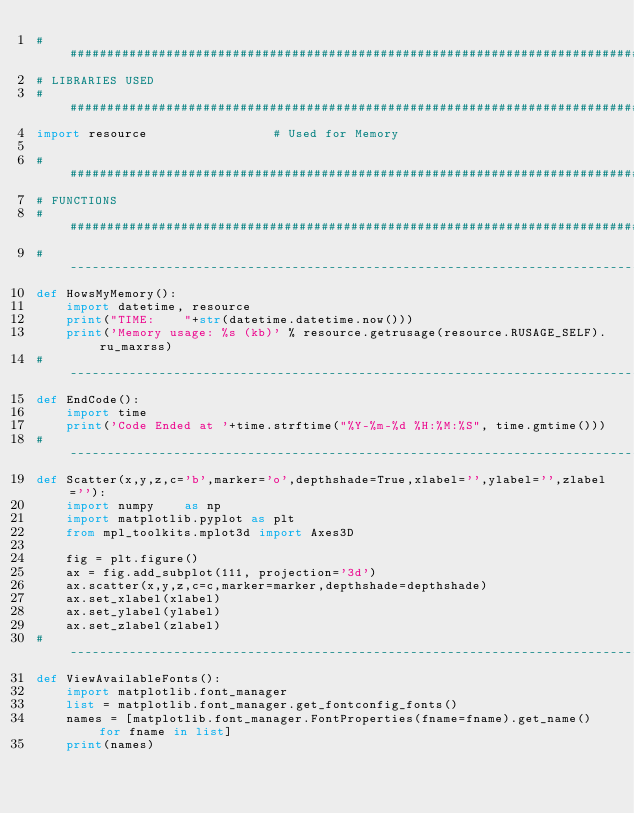Convert code to text. <code><loc_0><loc_0><loc_500><loc_500><_Python_>################################################################################
# LIBRARIES USED
################################################################################
import resource                 # Used for Memory

################################################################################
# FUNCTIONS
################################################################################
#-------------------------------------------------------------------------------
def HowsMyMemory():
    import datetime, resource
    print("TIME:    "+str(datetime.datetime.now()))
    print('Memory usage: %s (kb)' % resource.getrusage(resource.RUSAGE_SELF).ru_maxrss)
#-------------------------------------------------------------------------------
def EndCode():
    import time
    print('Code Ended at '+time.strftime("%Y-%m-%d %H:%M:%S", time.gmtime()))
#-------------------------------------------------------------------------------
def Scatter(x,y,z,c='b',marker='o',depthshade=True,xlabel='',ylabel='',zlabel=''):
    import numpy    as np
    import matplotlib.pyplot as plt
    from mpl_toolkits.mplot3d import Axes3D

    fig = plt.figure()
    ax = fig.add_subplot(111, projection='3d')
    ax.scatter(x,y,z,c=c,marker=marker,depthshade=depthshade)
    ax.set_xlabel(xlabel)
    ax.set_ylabel(ylabel)
    ax.set_zlabel(zlabel)
#-------------------------------------------------------------------------------
def ViewAvailableFonts():
    import matplotlib.font_manager
    list = matplotlib.font_manager.get_fontconfig_fonts()
    names = [matplotlib.font_manager.FontProperties(fname=fname).get_name() for fname in list]
    print(names)</code> 